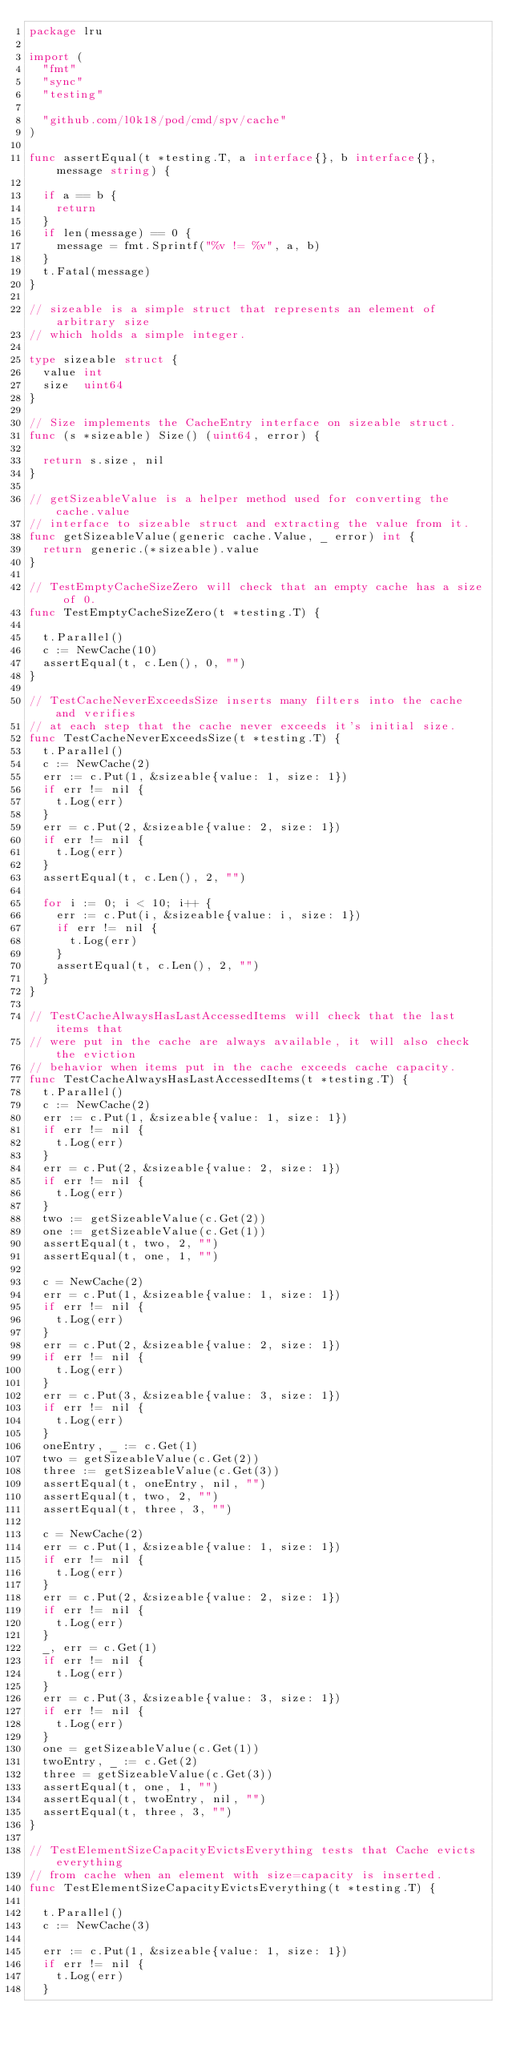Convert code to text. <code><loc_0><loc_0><loc_500><loc_500><_Go_>package lru

import (
	"fmt"
	"sync"
	"testing"

	"github.com/l0k18/pod/cmd/spv/cache"
)

func assertEqual(t *testing.T, a interface{}, b interface{}, message string) {

	if a == b {
		return
	}
	if len(message) == 0 {
		message = fmt.Sprintf("%v != %v", a, b)
	}
	t.Fatal(message)
}

// sizeable is a simple struct that represents an element of arbitrary size
// which holds a simple integer.

type sizeable struct {
	value int
	size  uint64
}

// Size implements the CacheEntry interface on sizeable struct.
func (s *sizeable) Size() (uint64, error) {

	return s.size, nil
}

// getSizeableValue is a helper method used for converting the cache.value
// interface to sizeable struct and extracting the value from it.
func getSizeableValue(generic cache.Value, _ error) int {
	return generic.(*sizeable).value
}

// TestEmptyCacheSizeZero will check that an empty cache has a size of 0.
func TestEmptyCacheSizeZero(t *testing.T) {

	t.Parallel()
	c := NewCache(10)
	assertEqual(t, c.Len(), 0, "")
}

// TestCacheNeverExceedsSize inserts many filters into the cache and verifies
// at each step that the cache never exceeds it's initial size.
func TestCacheNeverExceedsSize(t *testing.T) {
	t.Parallel()
	c := NewCache(2)
	err := c.Put(1, &sizeable{value: 1, size: 1})
	if err != nil {
		t.Log(err)
	}
	err = c.Put(2, &sizeable{value: 2, size: 1})
	if err != nil {
		t.Log(err)
	}
	assertEqual(t, c.Len(), 2, "")

	for i := 0; i < 10; i++ {
		err := c.Put(i, &sizeable{value: i, size: 1})
		if err != nil {
			t.Log(err)
		}
		assertEqual(t, c.Len(), 2, "")
	}
}

// TestCacheAlwaysHasLastAccessedItems will check that the last items that
// were put in the cache are always available, it will also check the eviction
// behavior when items put in the cache exceeds cache capacity.
func TestCacheAlwaysHasLastAccessedItems(t *testing.T) {
	t.Parallel()
	c := NewCache(2)
	err := c.Put(1, &sizeable{value: 1, size: 1})
	if err != nil {
		t.Log(err)
	}
	err = c.Put(2, &sizeable{value: 2, size: 1})
	if err != nil {
		t.Log(err)
	}
	two := getSizeableValue(c.Get(2))
	one := getSizeableValue(c.Get(1))
	assertEqual(t, two, 2, "")
	assertEqual(t, one, 1, "")

	c = NewCache(2)
	err = c.Put(1, &sizeable{value: 1, size: 1})
	if err != nil {
		t.Log(err)
	}
	err = c.Put(2, &sizeable{value: 2, size: 1})
	if err != nil {
		t.Log(err)
	}
	err = c.Put(3, &sizeable{value: 3, size: 1})
	if err != nil {
		t.Log(err)
	}
	oneEntry, _ := c.Get(1)
	two = getSizeableValue(c.Get(2))
	three := getSizeableValue(c.Get(3))
	assertEqual(t, oneEntry, nil, "")
	assertEqual(t, two, 2, "")
	assertEqual(t, three, 3, "")

	c = NewCache(2)
	err = c.Put(1, &sizeable{value: 1, size: 1})
	if err != nil {
		t.Log(err)
	}
	err = c.Put(2, &sizeable{value: 2, size: 1})
	if err != nil {
		t.Log(err)
	}
	_, err = c.Get(1)
	if err != nil {
		t.Log(err)
	}
	err = c.Put(3, &sizeable{value: 3, size: 1})
	if err != nil {
		t.Log(err)
	}
	one = getSizeableValue(c.Get(1))
	twoEntry, _ := c.Get(2)
	three = getSizeableValue(c.Get(3))
	assertEqual(t, one, 1, "")
	assertEqual(t, twoEntry, nil, "")
	assertEqual(t, three, 3, "")
}

// TestElementSizeCapacityEvictsEverything tests that Cache evicts everything
// from cache when an element with size=capacity is inserted.
func TestElementSizeCapacityEvictsEverything(t *testing.T) {

	t.Parallel()
	c := NewCache(3)

	err := c.Put(1, &sizeable{value: 1, size: 1})
	if err != nil {
		t.Log(err)
	}</code> 